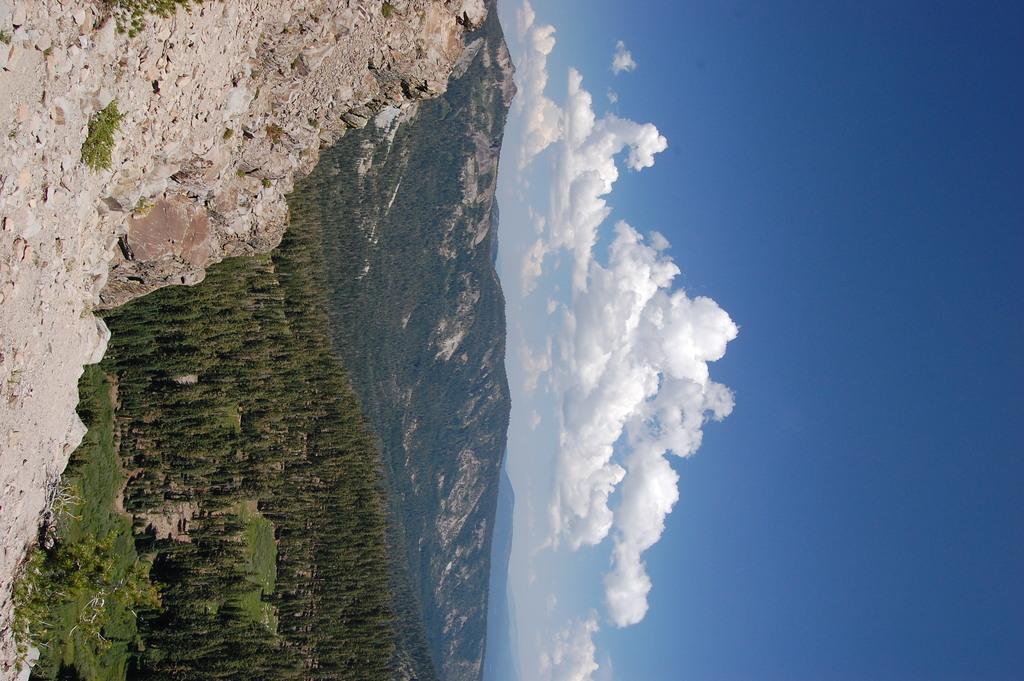In one or two sentences, can you explain what this image depicts? In this picture we can see rocks, trees, mountains and in the background we can see the sky with clouds. 